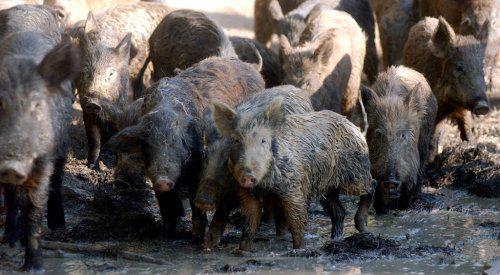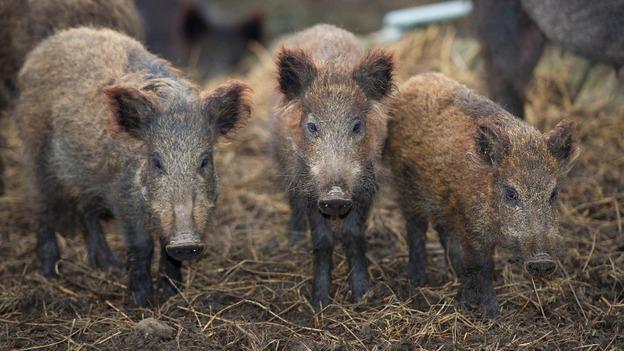The first image is the image on the left, the second image is the image on the right. Given the left and right images, does the statement "There are no more than 4 animals in the image on the right." hold true? Answer yes or no. Yes. 